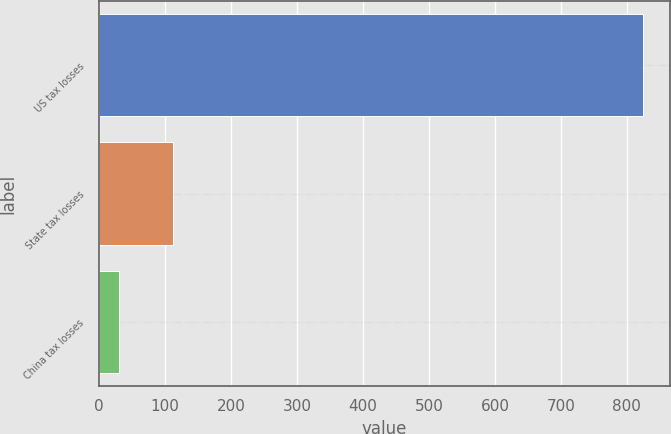Convert chart to OTSL. <chart><loc_0><loc_0><loc_500><loc_500><bar_chart><fcel>US tax losses<fcel>State tax losses<fcel>China tax losses<nl><fcel>824<fcel>112<fcel>30<nl></chart> 